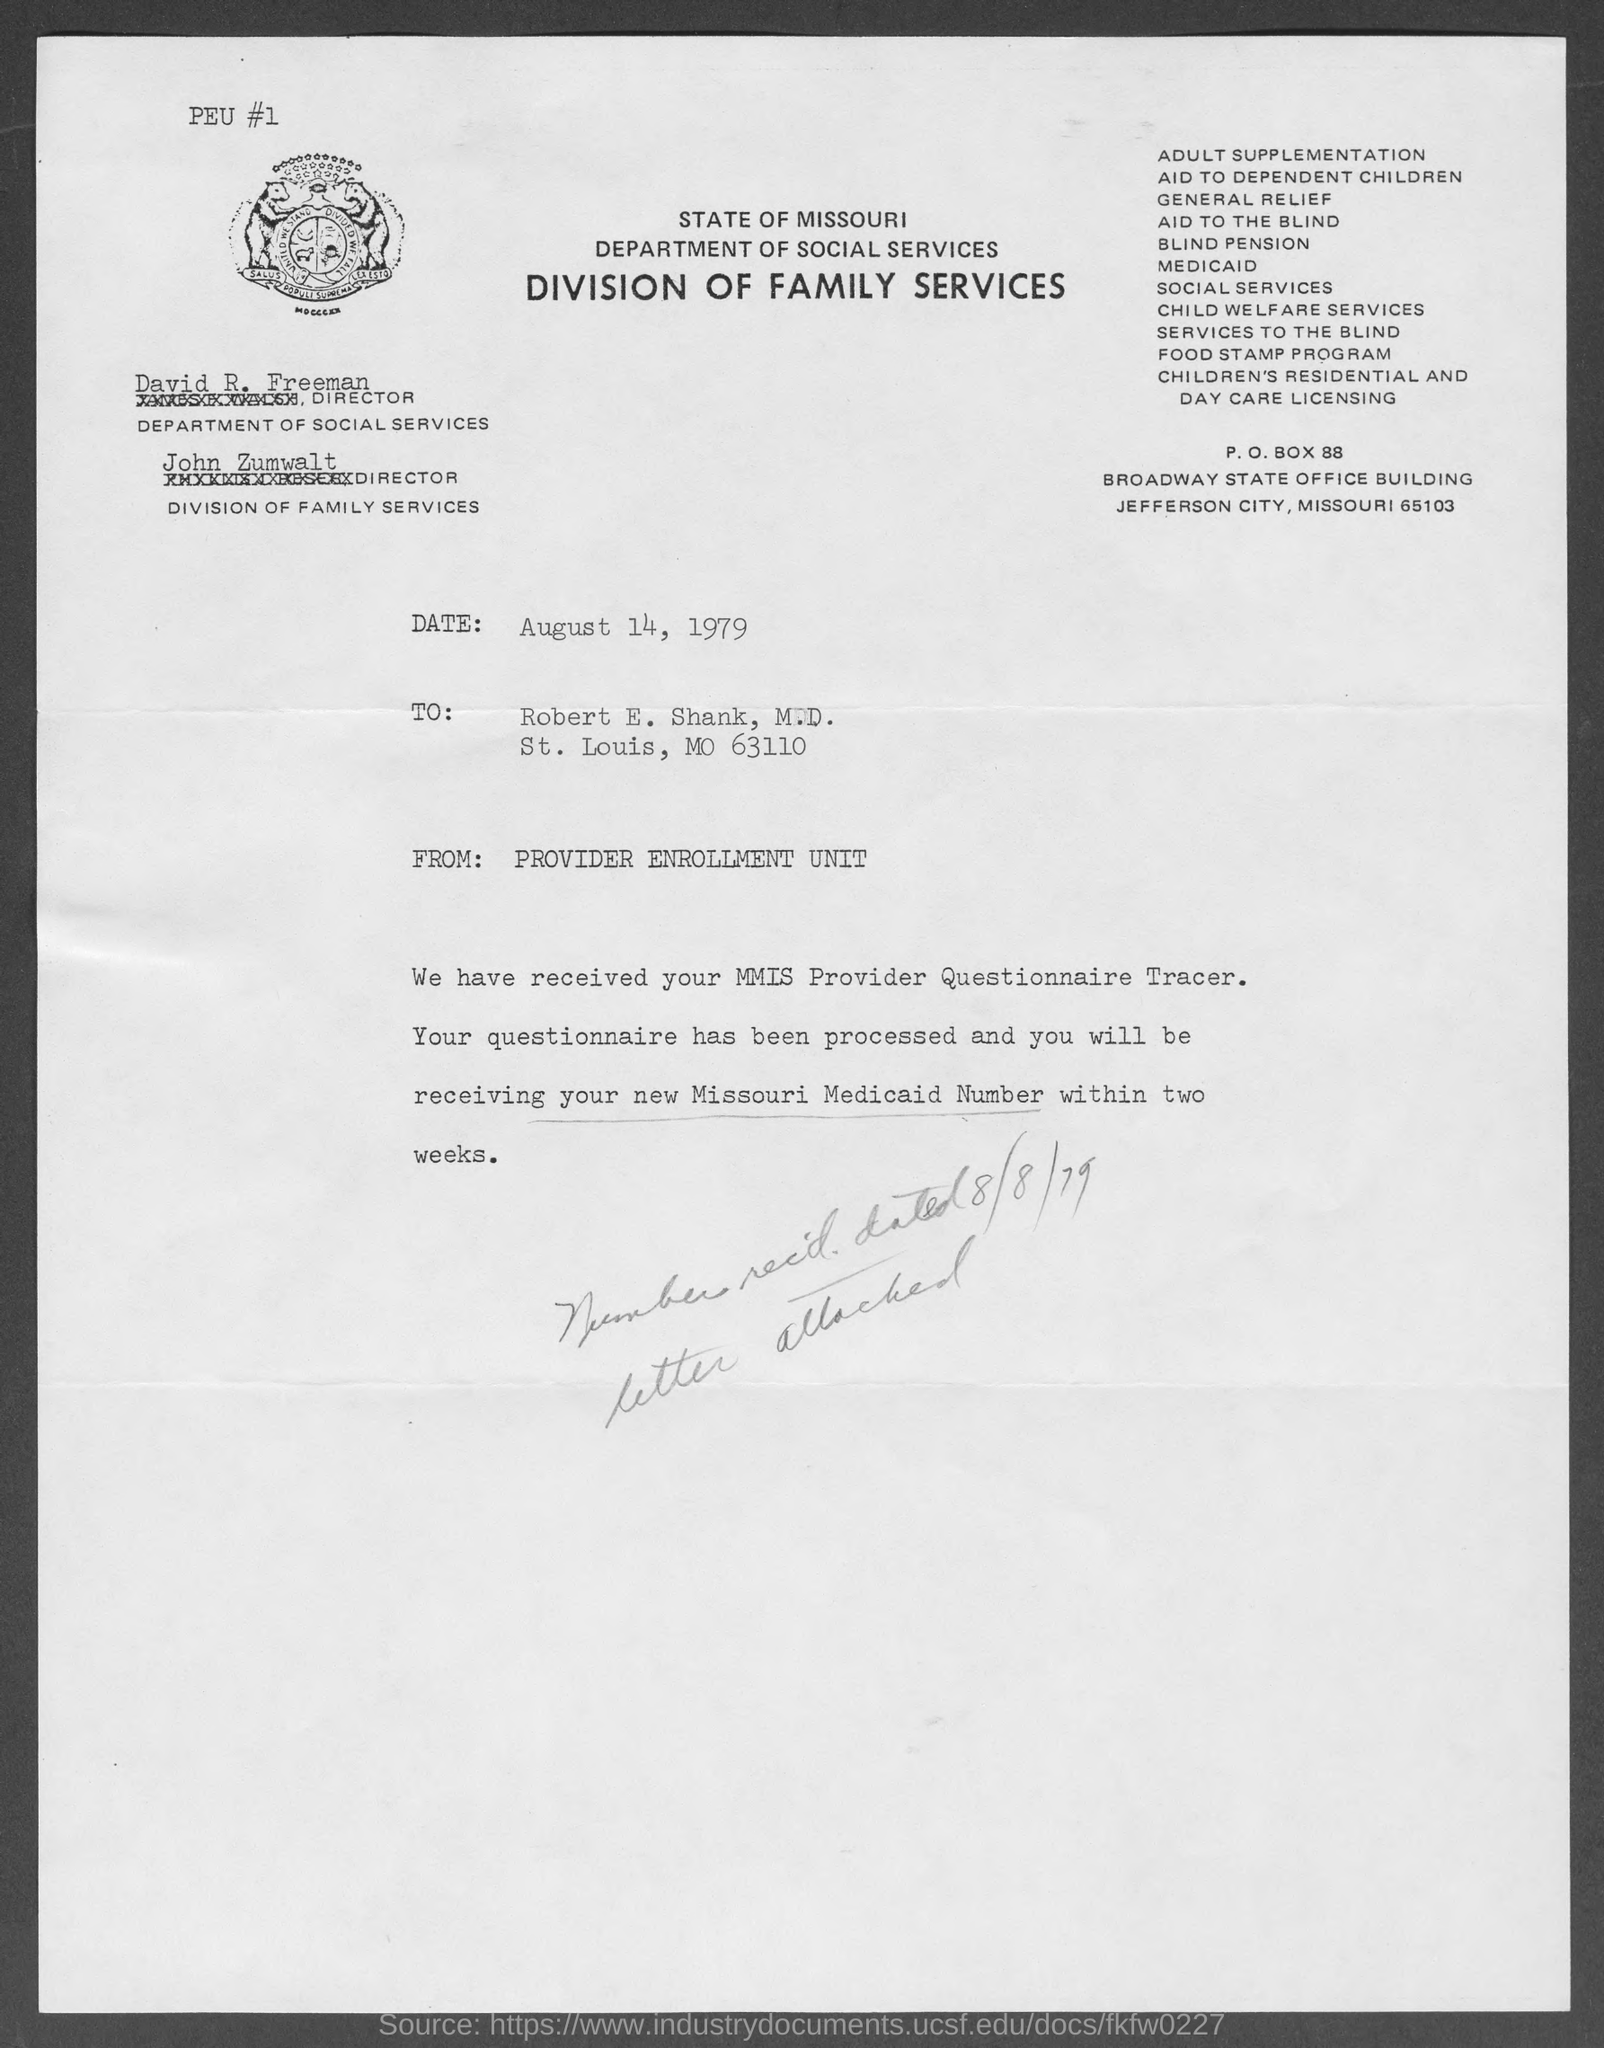Specify some key components in this picture. The Director of the Department of Social Services is David R. Freeman. The date mentioned in the document is August 14, 1979. The Director of the Division of Family Services is John Zumwalt. The P.O. Box number of the State of Missouri Department of Social Services and Division of Family Services is 88. 